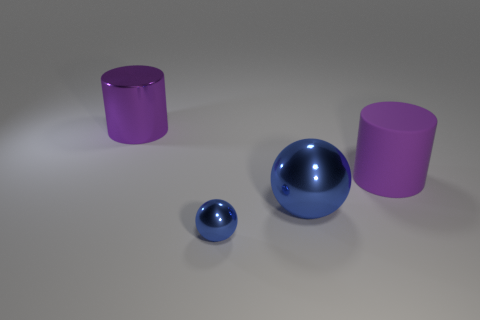Add 4 cyan spheres. How many objects exist? 8 Subtract 0 cyan blocks. How many objects are left? 4 Subtract all large purple metallic objects. Subtract all tiny cyan things. How many objects are left? 3 Add 4 big shiny cylinders. How many big shiny cylinders are left? 5 Add 4 large purple shiny cylinders. How many large purple shiny cylinders exist? 5 